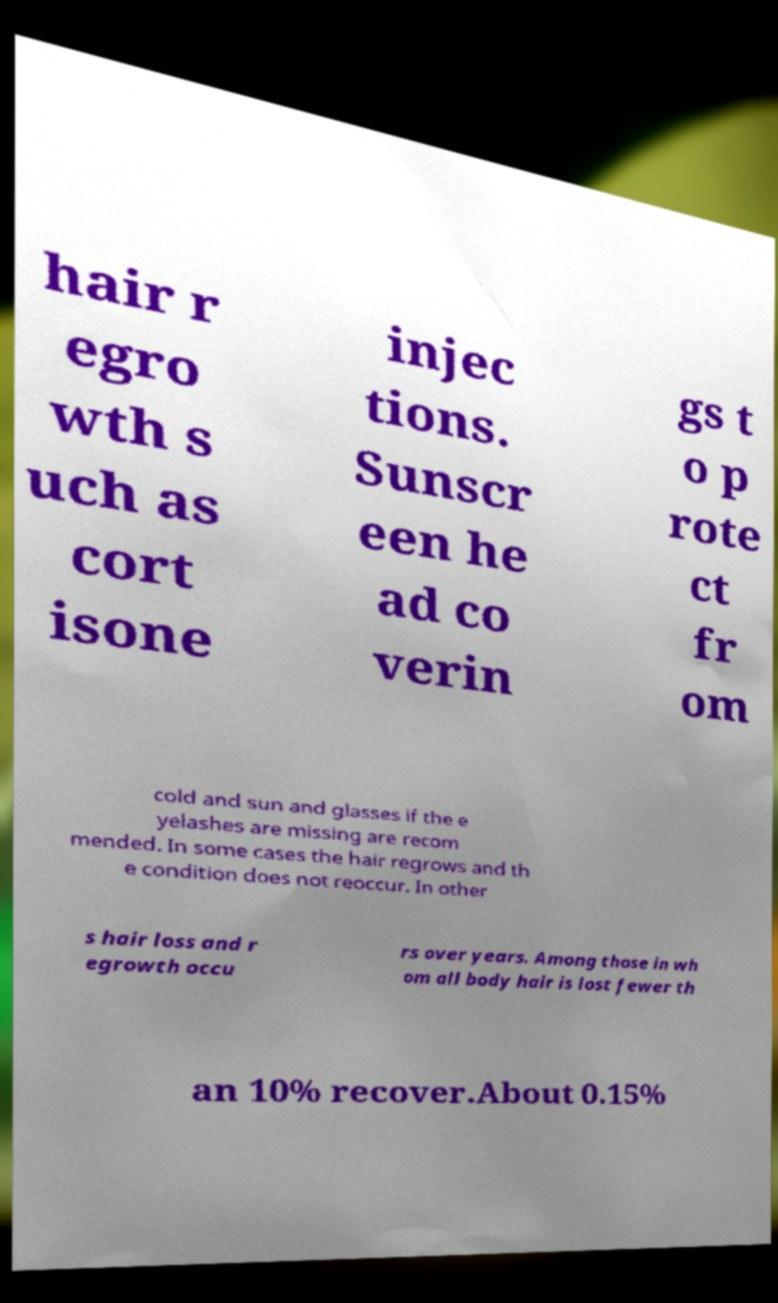Could you extract and type out the text from this image? hair r egro wth s uch as cort isone injec tions. Sunscr een he ad co verin gs t o p rote ct fr om cold and sun and glasses if the e yelashes are missing are recom mended. In some cases the hair regrows and th e condition does not reoccur. In other s hair loss and r egrowth occu rs over years. Among those in wh om all body hair is lost fewer th an 10% recover.About 0.15% 